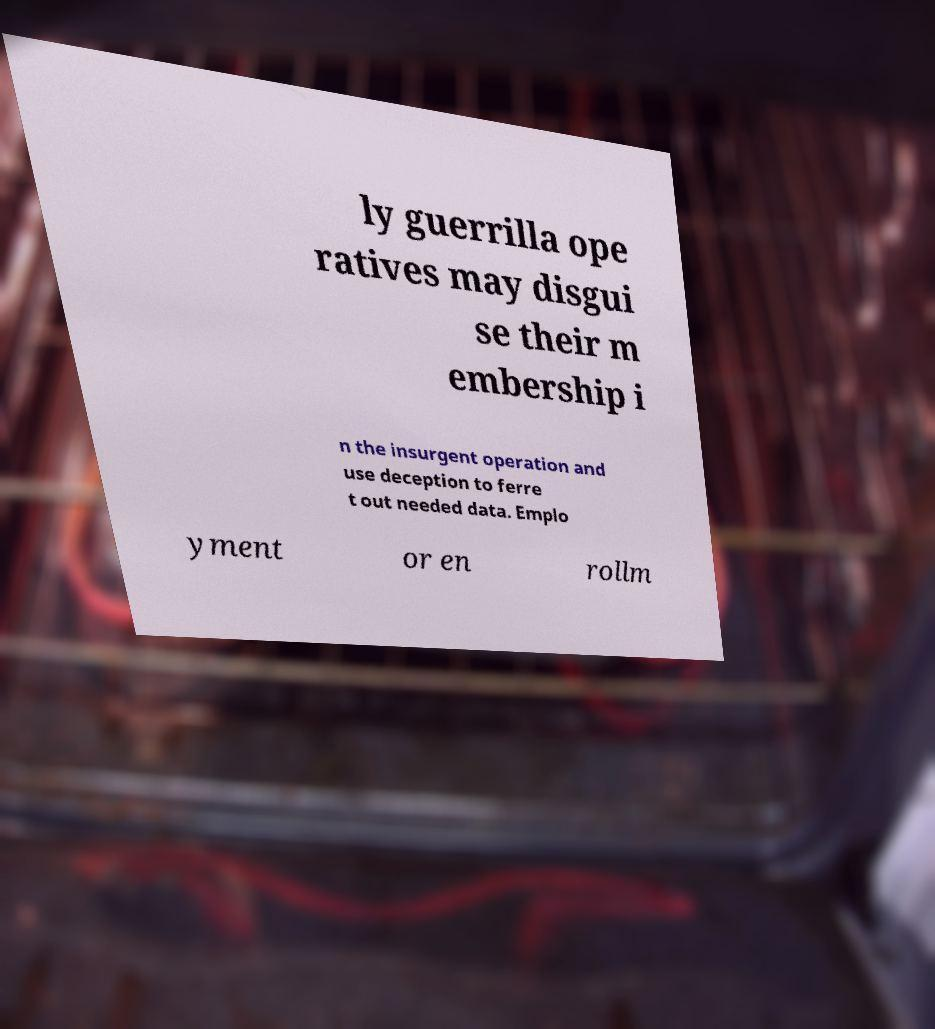Can you read and provide the text displayed in the image?This photo seems to have some interesting text. Can you extract and type it out for me? ly guerrilla ope ratives may disgui se their m embership i n the insurgent operation and use deception to ferre t out needed data. Emplo yment or en rollm 